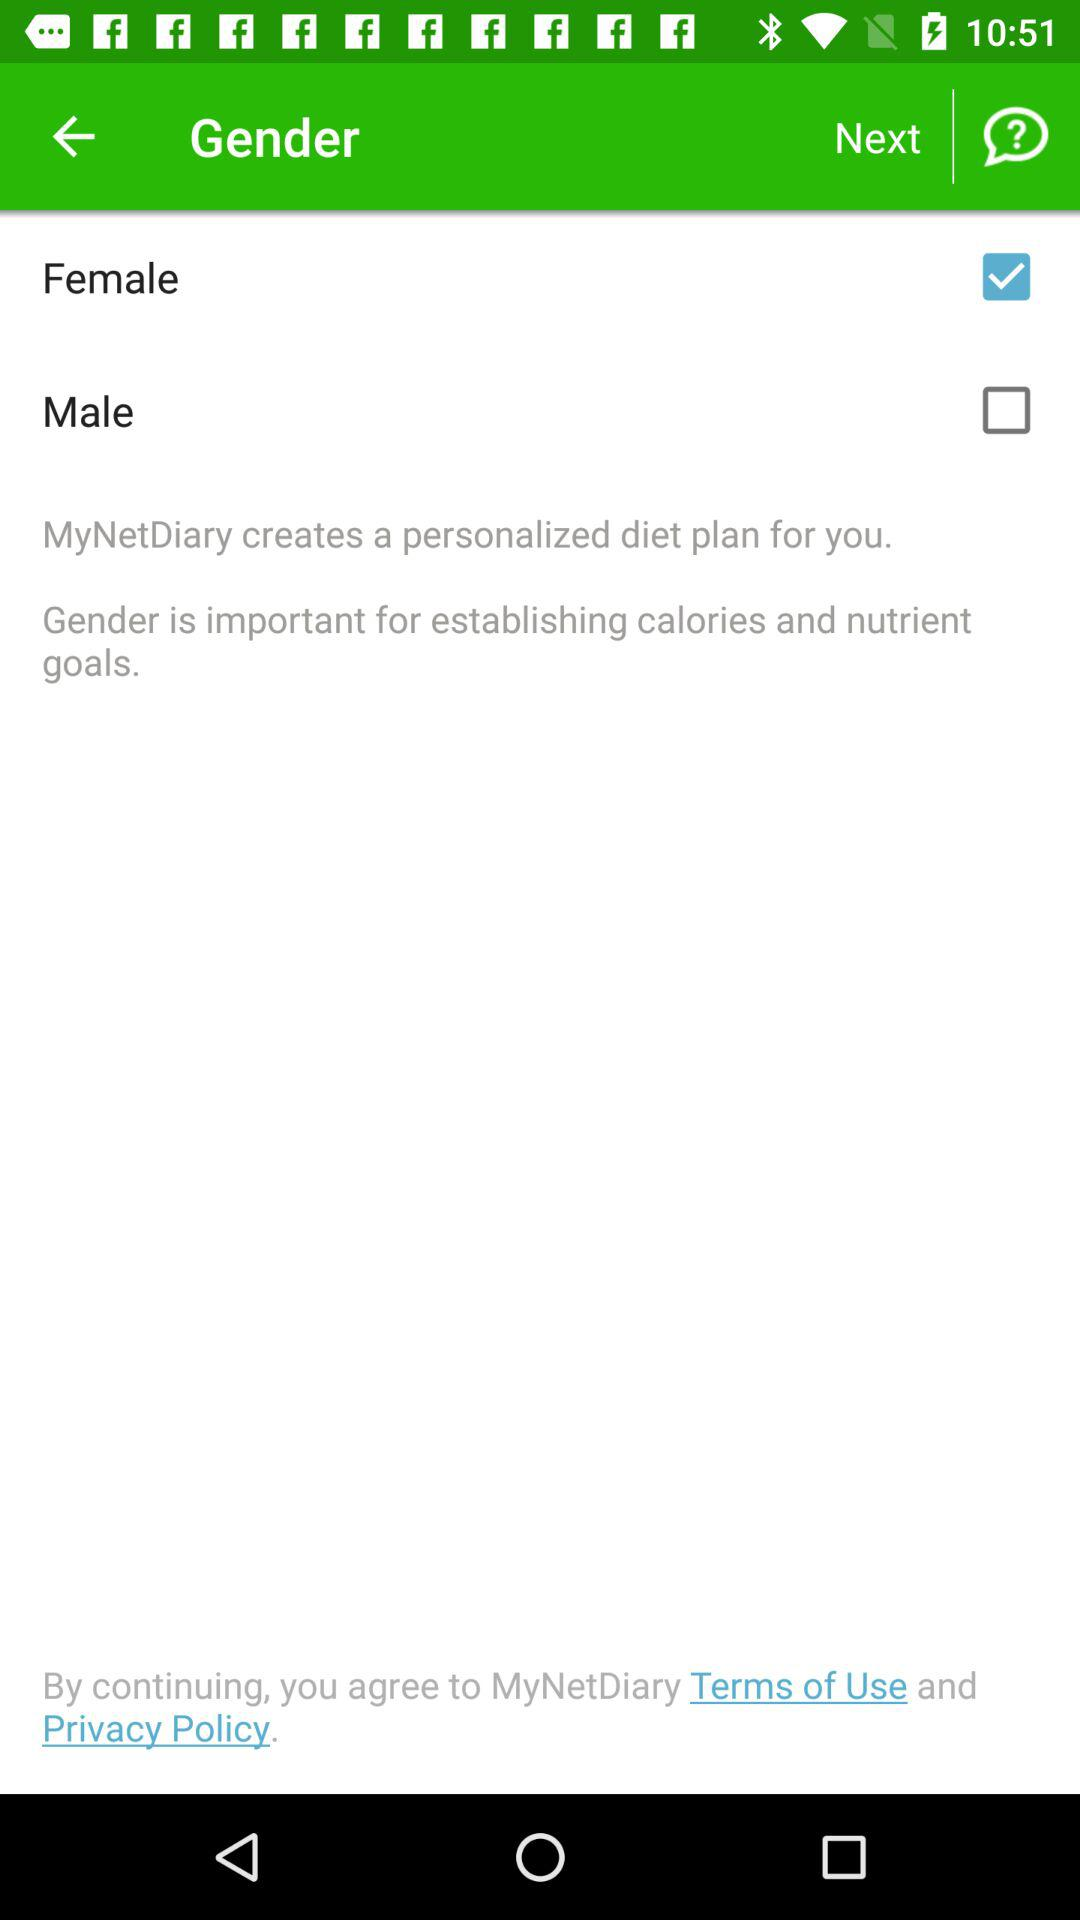Which option is selected? The selected option is "Female". 